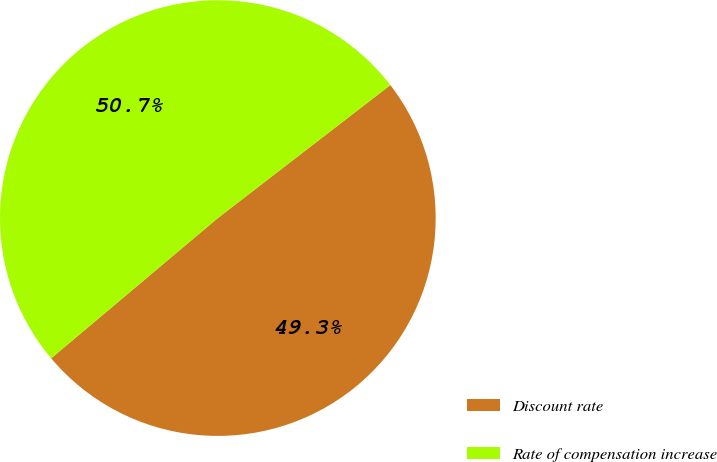<chart> <loc_0><loc_0><loc_500><loc_500><pie_chart><fcel>Discount rate<fcel>Rate of compensation increase<nl><fcel>49.32%<fcel>50.68%<nl></chart> 